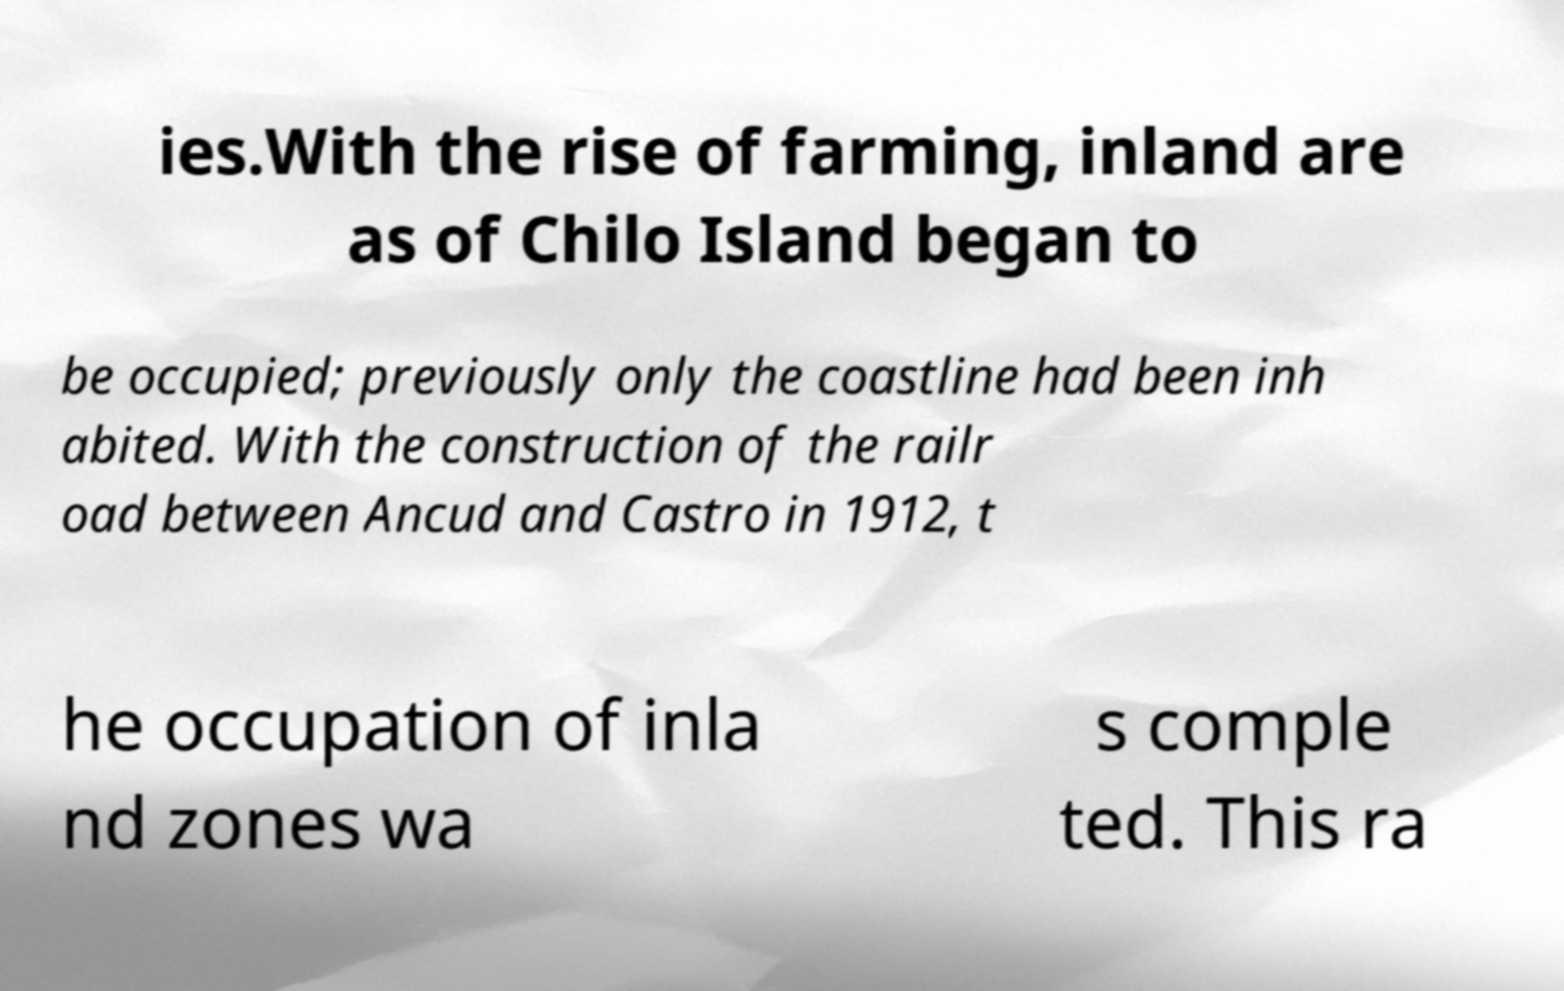There's text embedded in this image that I need extracted. Can you transcribe it verbatim? ies.With the rise of farming, inland are as of Chilo Island began to be occupied; previously only the coastline had been inh abited. With the construction of the railr oad between Ancud and Castro in 1912, t he occupation of inla nd zones wa s comple ted. This ra 